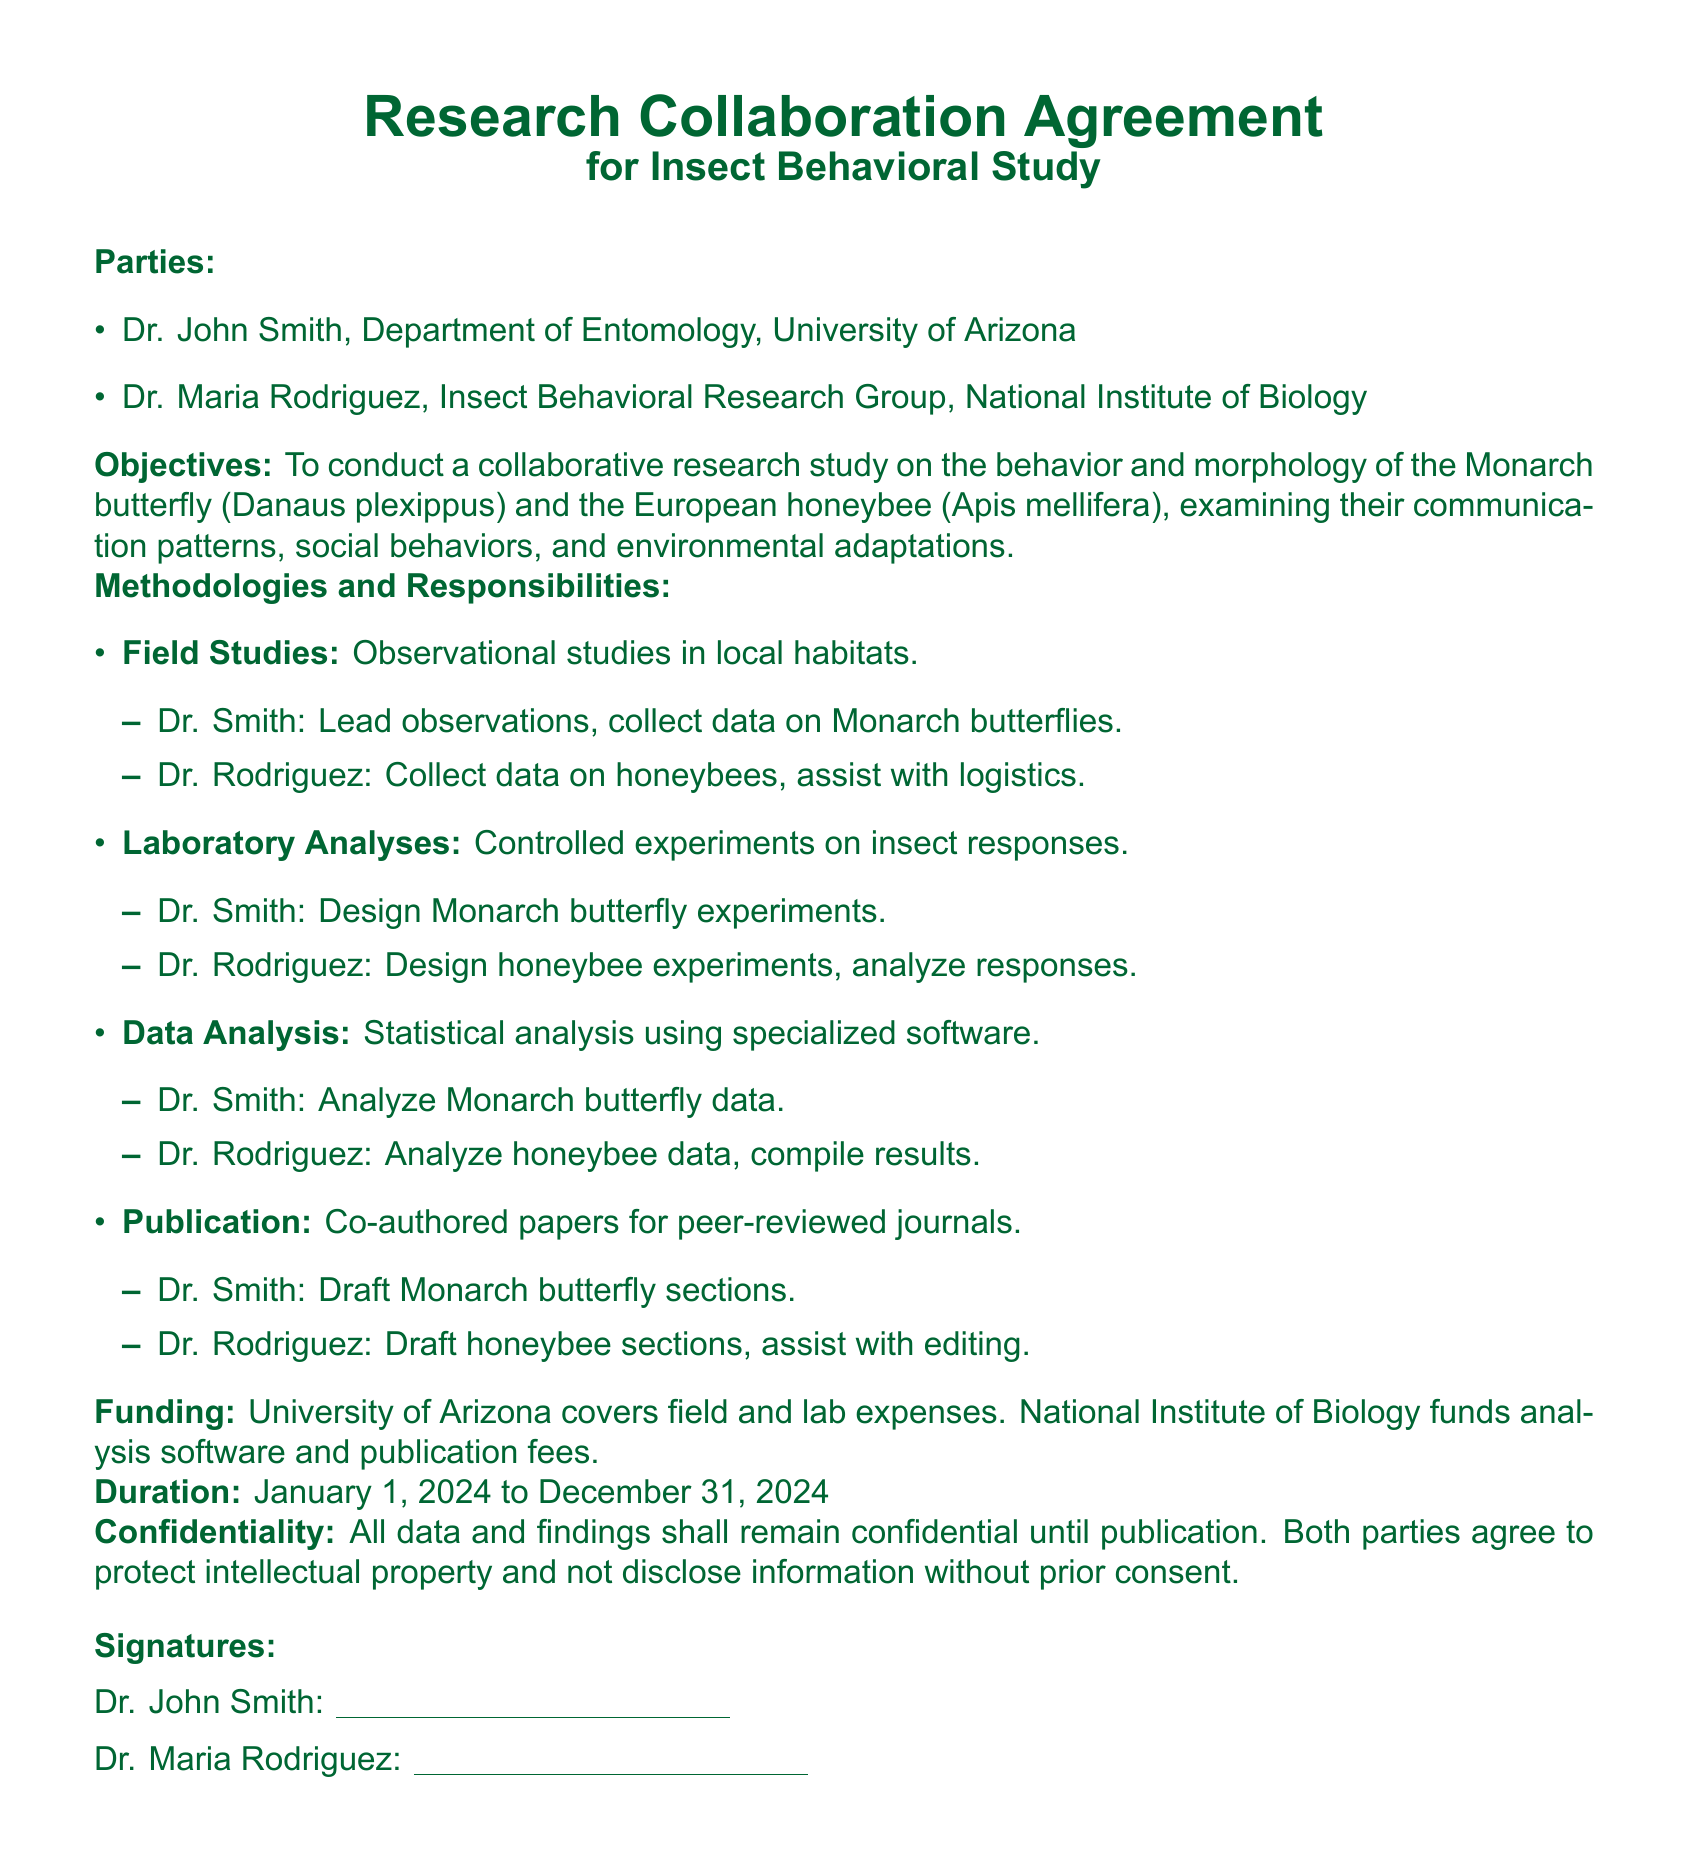what are the names of the collaborating parties? The parties involved in the collaboration are specified in the document as Dr. John Smith and Dr. Maria Rodriguez.
Answer: Dr. John Smith, Dr. Maria Rodriguez what is the duration of the research collaboration? The document specifies that the duration of the collaboration is from January 1, 2024 to December 31, 2024.
Answer: January 1, 2024 to December 31, 2024 who is responsible for collecting data on Monarch butterflies? The document assigns Dr. Smith the responsibility to lead observations and collect data on Monarch butterflies.
Answer: Dr. Smith what subject will Dr. Rodriguez analyze in the laboratory? The responsibilities outlined in the document state that Dr. Rodriguez will design experiments and analyze responses related to honeybees.
Answer: honeybees what is the funding source for field and lab expenses? The document mentions that field and lab expenses are covered by the University of Arizona.
Answer: University of Arizona what is the primary objective of the collaboration? The main goal of the collaborative research mentioned in the document is to study the behavior and morphology of specific insect species, specifically Monarch butterflies and honeybees.
Answer: Insect behavioral study how will the parties handle confidentiality? The document states that all data and findings are to remain confidential until publication.
Answer: Confidential until publication who is responsible for drafting the honeybee sections of the publication? The document specifies that Dr. Rodriguez will draft the honeybee sections of the co-authored papers.
Answer: Dr. Rodriguez 